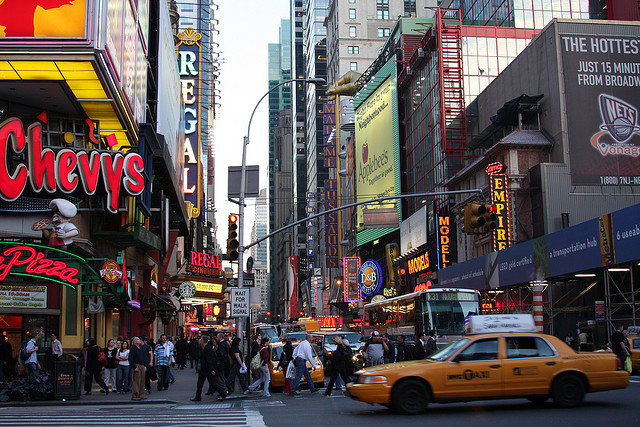What can we infer about the businesses visible in the picture? The image includes a variety of businesses such as restaurants, entertainment venues, and retail stores. These establishments, particularly the prominent signage of chains like 'Chevys' and 'Dave & Busters', suggest a commercial area designed to attract both tourists and local visitors, offering dining, shopping, and entertainment options. 